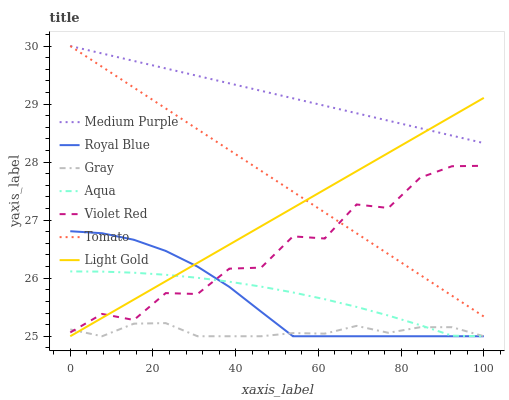Does Gray have the minimum area under the curve?
Answer yes or no. Yes. Does Medium Purple have the maximum area under the curve?
Answer yes or no. Yes. Does Violet Red have the minimum area under the curve?
Answer yes or no. No. Does Violet Red have the maximum area under the curve?
Answer yes or no. No. Is Light Gold the smoothest?
Answer yes or no. Yes. Is Violet Red the roughest?
Answer yes or no. Yes. Is Gray the smoothest?
Answer yes or no. No. Is Gray the roughest?
Answer yes or no. No. Does Gray have the lowest value?
Answer yes or no. Yes. Does Violet Red have the lowest value?
Answer yes or no. No. Does Medium Purple have the highest value?
Answer yes or no. Yes. Does Violet Red have the highest value?
Answer yes or no. No. Is Gray less than Tomato?
Answer yes or no. Yes. Is Medium Purple greater than Royal Blue?
Answer yes or no. Yes. Does Tomato intersect Violet Red?
Answer yes or no. Yes. Is Tomato less than Violet Red?
Answer yes or no. No. Is Tomato greater than Violet Red?
Answer yes or no. No. Does Gray intersect Tomato?
Answer yes or no. No. 